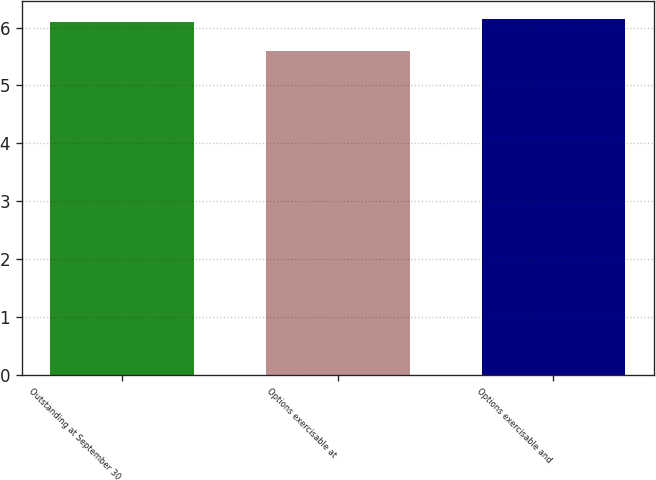<chart> <loc_0><loc_0><loc_500><loc_500><bar_chart><fcel>Outstanding at September 30<fcel>Options exercisable at<fcel>Options exercisable and<nl><fcel>6.1<fcel>5.6<fcel>6.15<nl></chart> 